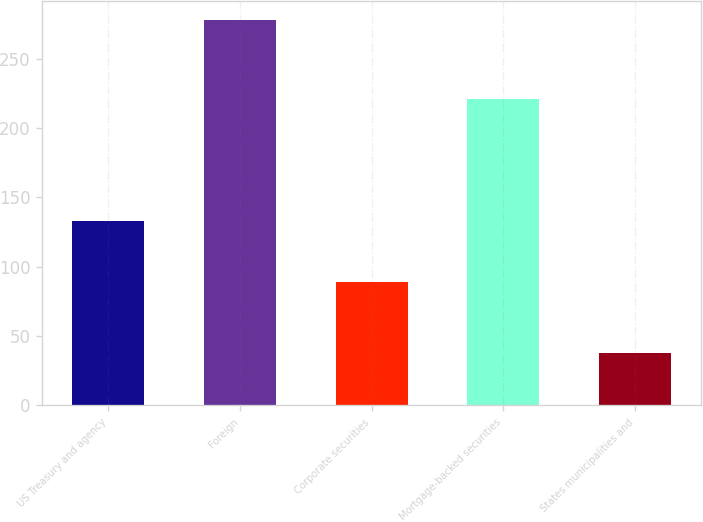Convert chart. <chart><loc_0><loc_0><loc_500><loc_500><bar_chart><fcel>US Treasury and agency<fcel>Foreign<fcel>Corporate securities<fcel>Mortgage-backed securities<fcel>States municipalities and<nl><fcel>133<fcel>278<fcel>89<fcel>221<fcel>38<nl></chart> 